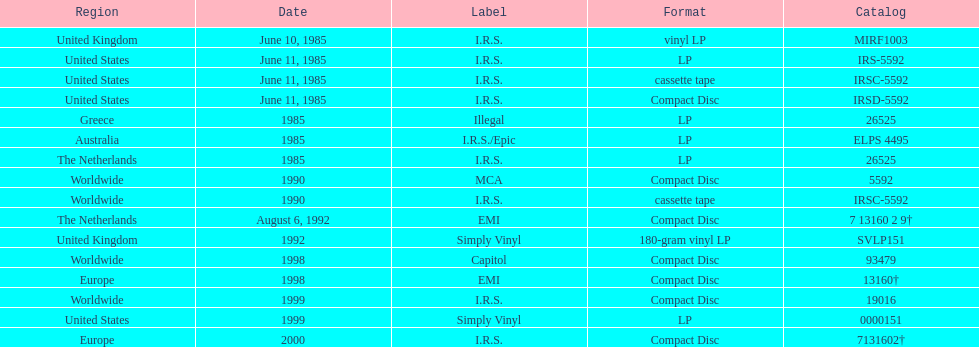Name another region for the 1985 release other than greece. Australia. 